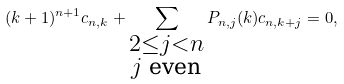Convert formula to latex. <formula><loc_0><loc_0><loc_500><loc_500>( k + 1 ) ^ { n + 1 } c _ { n , k } + \sum _ { \substack { 2 \leq j < n \\ \text {$j$  even} } } { P _ { n , j } ( k ) c _ { n , k + j } } = 0 ,</formula> 